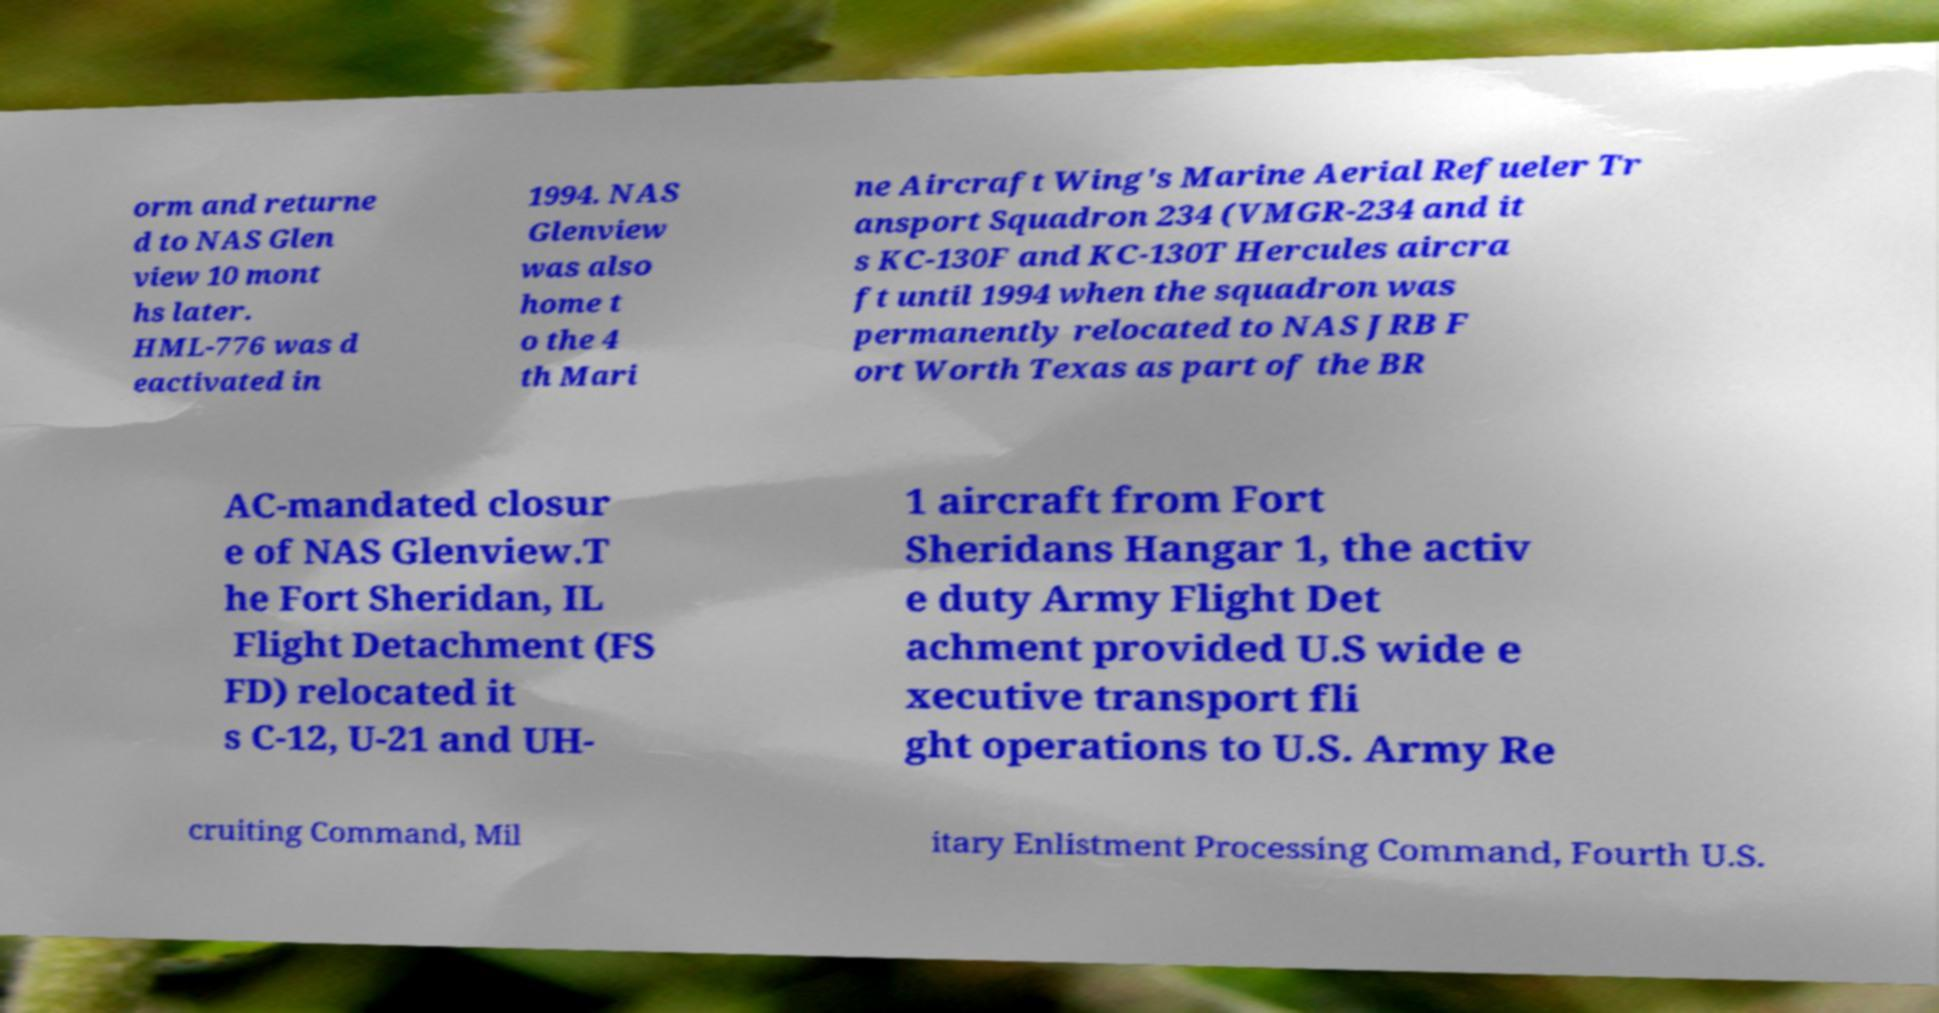Can you read and provide the text displayed in the image?This photo seems to have some interesting text. Can you extract and type it out for me? orm and returne d to NAS Glen view 10 mont hs later. HML-776 was d eactivated in 1994. NAS Glenview was also home t o the 4 th Mari ne Aircraft Wing's Marine Aerial Refueler Tr ansport Squadron 234 (VMGR-234 and it s KC-130F and KC-130T Hercules aircra ft until 1994 when the squadron was permanently relocated to NAS JRB F ort Worth Texas as part of the BR AC-mandated closur e of NAS Glenview.T he Fort Sheridan, IL Flight Detachment (FS FD) relocated it s C-12, U-21 and UH- 1 aircraft from Fort Sheridans Hangar 1, the activ e duty Army Flight Det achment provided U.S wide e xecutive transport fli ght operations to U.S. Army Re cruiting Command, Mil itary Enlistment Processing Command, Fourth U.S. 